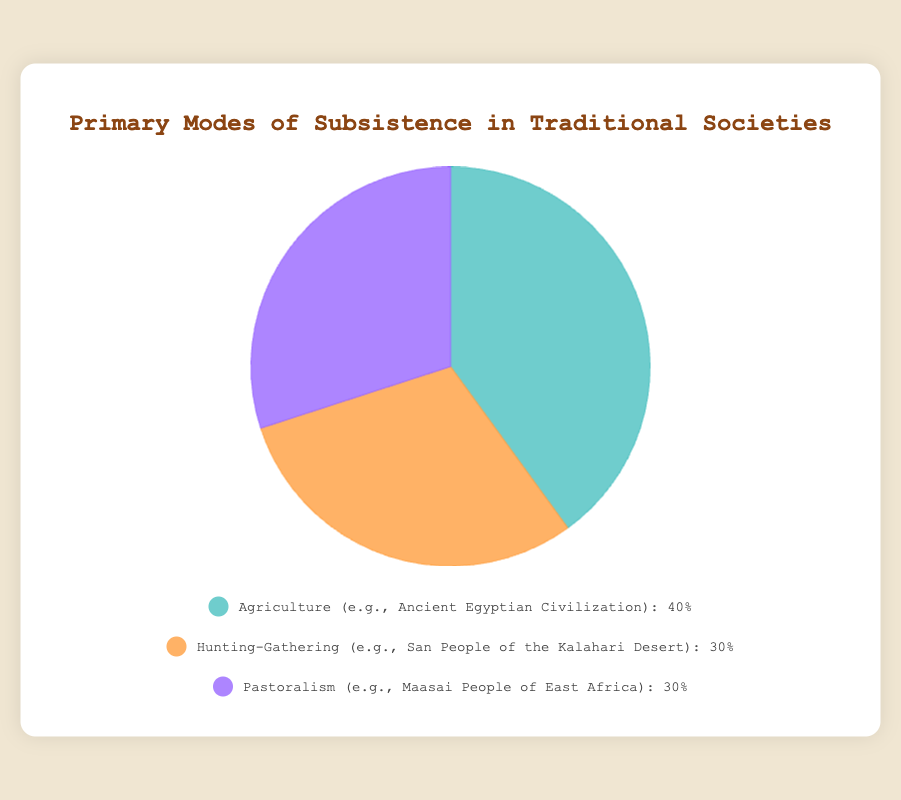What is the most common primary mode of subsistence in traditional societies according to the pie chart? The pie chart shows three modes of subsistence with Agriculture having the highest percentage at 40. This makes Agriculture the most common mode.
Answer: Agriculture Which two primary modes of subsistence are equally represented in this chart? Both Hunting-Gathering and Pastoralism have an equal percentage of 30, as indicated in the pie chart.
Answer: Hunting-Gathering and Pastoralism What is the combined percentage of societies primarily relying on Hunting-Gathering and Pastoralism? The pie chart shows Hunting-Gathering and Pastoralism each at 30%. Adding these together gives 30% + 30% = 60%.
Answer: 60% How much more common is Agriculture as a primary mode than either Hunting-Gathering or Pastoralism? Agriculture has a percentage of 40%, while Hunting-Gathering and Pastoralism each have 30%. The difference can be calculated as 40% - 30% = 10%.
Answer: 10% What color represents Pastoralism on the pie chart? The legend of the pie chart shows Pastoralism associated with a purple color.
Answer: Purple If a society combines both Agriculture and Hunting-Gathering equally, what percentage of traditional societies would this represent compared to societies relying on Pastoralism? Agriculture and Hunting-Gathering are 40% and 30% respectively. Combining them equally would imply an average, (40% + 30%) / 2 = 35%. Compared to Pastoralism's 30%, it would be 35% - 30% = 5% more.
Answer: 5% What proportion of societies do not primarily rely on Agriculture, according to the pie chart? Societies that do not primarily rely on Agriculture include those practicing Hunting-Gathering and Pastoralism. Adding their percentages gives 30% + 30% = 60%.
Answer: 60% Which primary mode of subsistence is associated with the color green according to the pie chart? The legend of the pie chart shows Agriculture associated with the green color.
Answer: Agriculture What is the average percentage of the three primary modes of subsistence? Summing the percentages of Agriculture (40%), Hunting-Gathering (30%), and Pastoralism (30%) gives 100%. Dividing by three modes will give (40% + 30% + 30%) / 3 = 33.33%.
Answer: 33.33% 